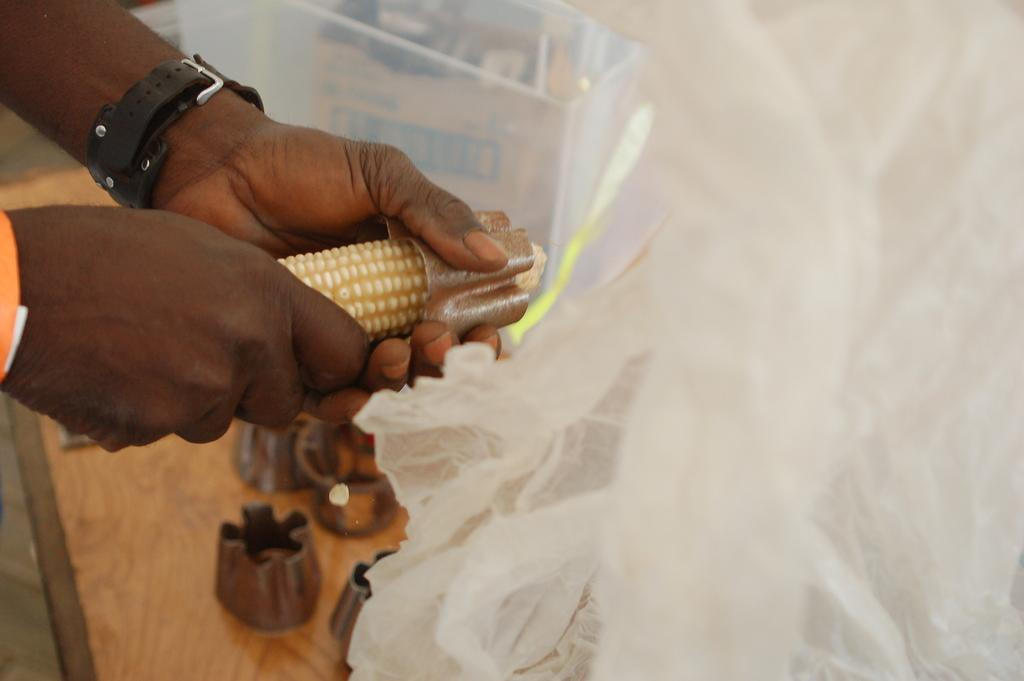What is the person holding in the image? The person's hands are holding maize in the image. What tool is visible in the image that is used for removing corn? There is a corn remover in the image. What can be seen at the bottom of the image? There is a curtain visible at the bottom of the image. Where are the corn removers placed in the image? The corn removers are placed on a table in the image. What story does the expert tell about the pigs in the image? There are no pigs or experts present in the image, so no such story can be told. 